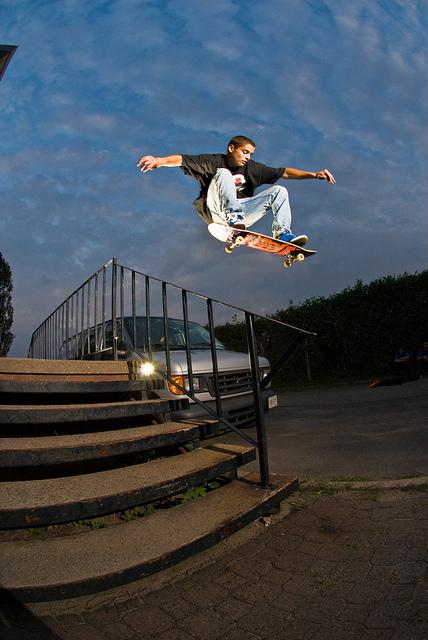The skateboarder would have to Ollie at least how high to clear the top of the railing?

Choices:
A) 12 feet
B) 8 feet
C) 5 feet
D) 3 feet 3 feet 